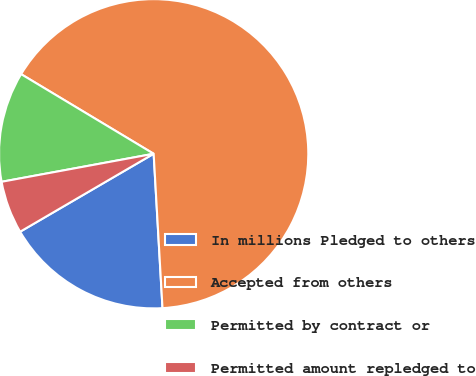Convert chart to OTSL. <chart><loc_0><loc_0><loc_500><loc_500><pie_chart><fcel>In millions Pledged to others<fcel>Accepted from others<fcel>Permitted by contract or<fcel>Permitted amount repledged to<nl><fcel>17.5%<fcel>65.48%<fcel>11.51%<fcel>5.51%<nl></chart> 